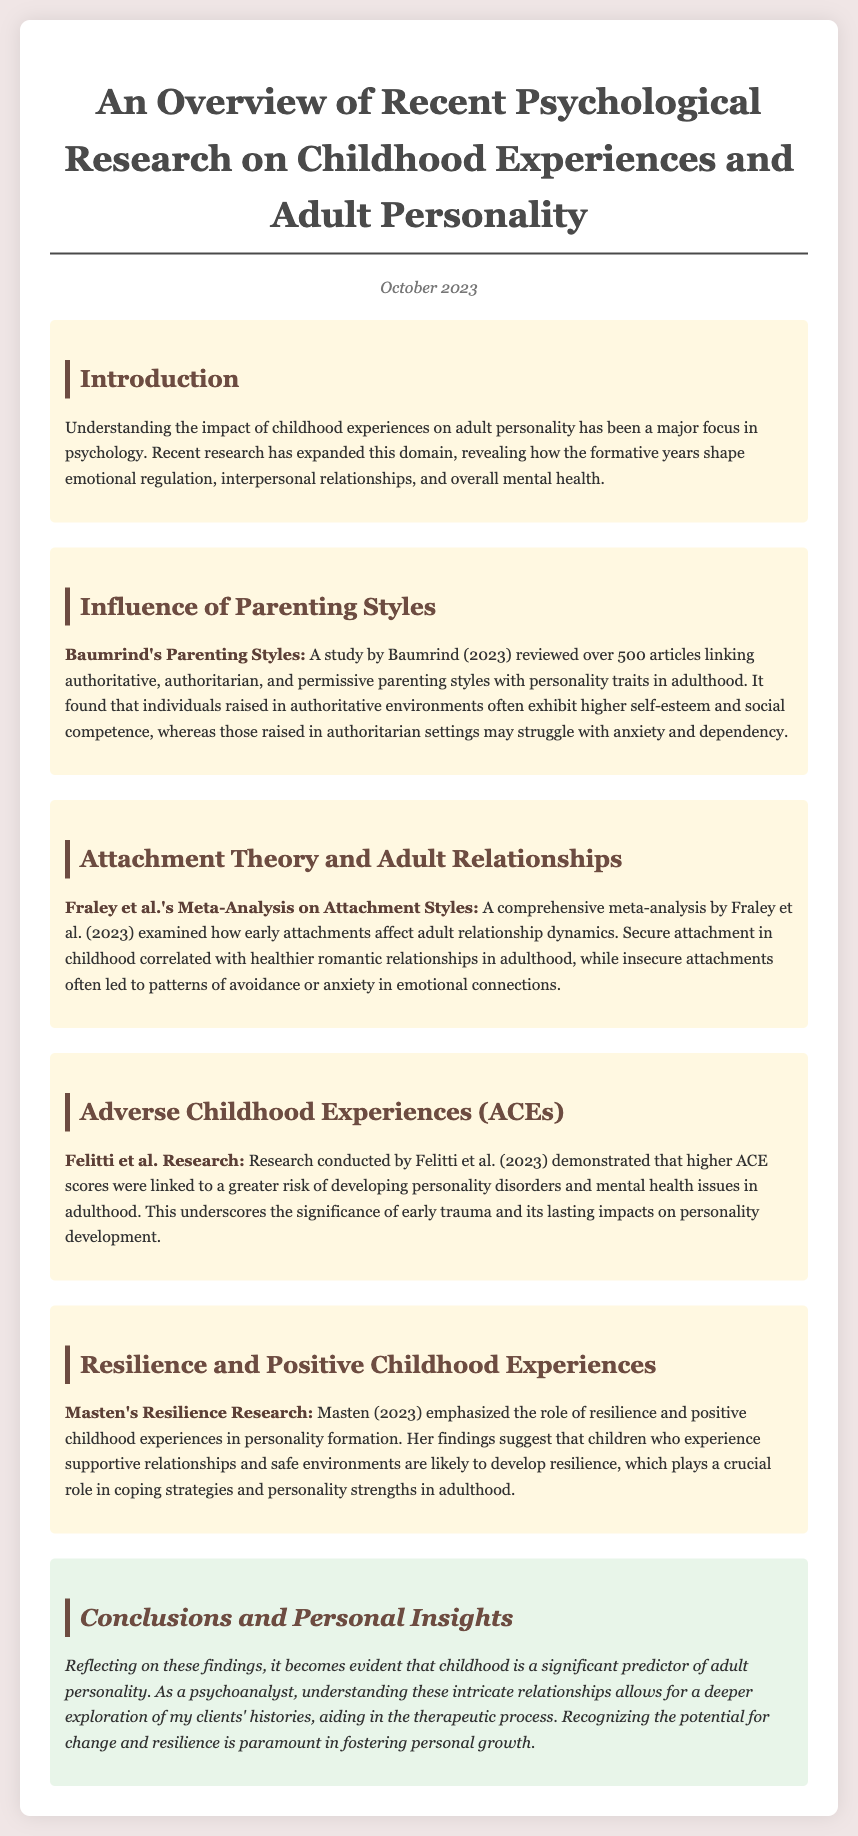What is the title of the document? The title of the document is presented prominently at the top.
Answer: An Overview of Recent Psychological Research on Childhood Experiences and Adult Personality Who conducted the meta-analysis on attachment styles? The document lists the authors of the meta-analysis in the section on attachment theory.
Answer: Fraley et al What year was Baumrind's study published? The publication year is mentioned at the beginning of the study section.
Answer: 2023 Which parenting style is linked to higher self-esteem? The study discusses the outcomes associated with different parenting styles.
Answer: Authoritative What major factor does Masten's research highlight? The research in this section discusses a specific element that supports personality development.
Answer: Resilience How do adverse childhood experiences (ACEs) relate to adult personality? The connection made in the document between ACEs and adult outcomes is outlined in the corresponding section.
Answer: Higher ACE scores linked to greater risk of personality disorders What is the conclusion drawn about childhood experiences? The conclusion section reflects on the earlier findings regarding the importance of childhood.
Answer: Significant predictor of adult personality What color is the background of the document? The background color is mentioned in the style section of the document.
Answer: #f0e6e6 